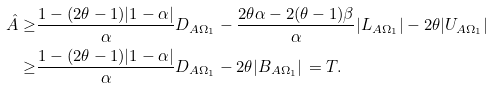Convert formula to latex. <formula><loc_0><loc_0><loc_500><loc_500>\hat { A } \geq & \frac { 1 - ( 2 \theta - 1 ) | 1 - \alpha | } { \alpha } D _ { A \Omega _ { 1 } } - \frac { 2 \theta \alpha - 2 ( \theta - 1 ) \beta } { \alpha } | L _ { A \Omega _ { 1 } } | - 2 \theta | U _ { A \Omega _ { 1 } } | \\ \geq & \frac { 1 - ( 2 \theta - 1 ) | 1 - \alpha | } { \alpha } D _ { A \Omega _ { 1 } } - 2 \theta | B _ { A \Omega _ { 1 } } | \, = T .</formula> 